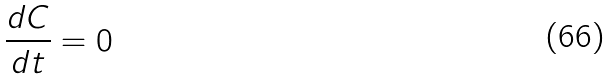Convert formula to latex. <formula><loc_0><loc_0><loc_500><loc_500>\frac { d C } { d t } = 0</formula> 